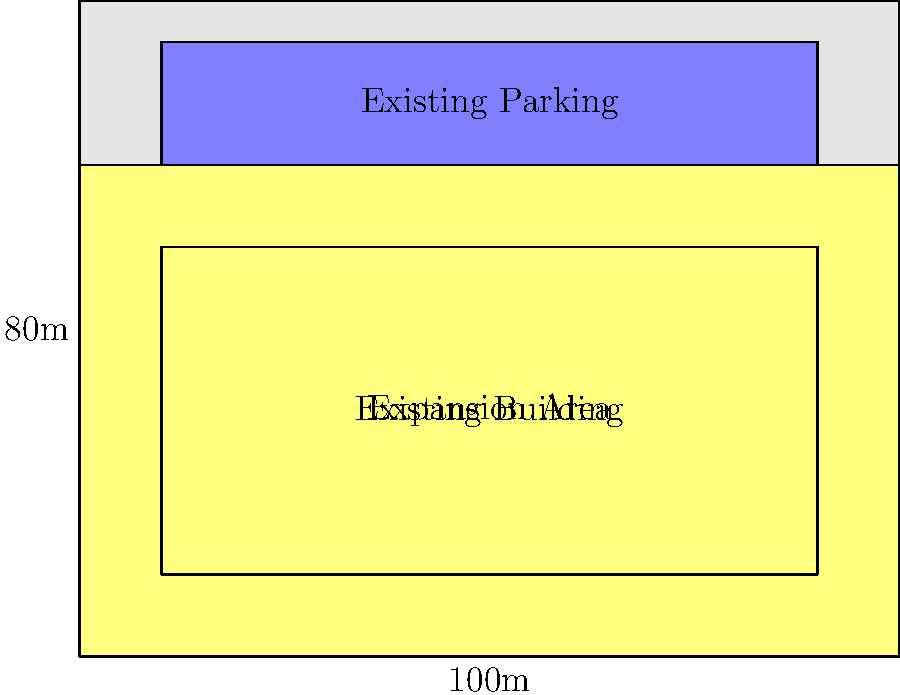As a family business owner looking to expand your operations, you've been presented with the following site plan for a parking lot expansion. Given that the expansion area is 100m wide and 60m deep, and assuming each parking space requires 5m x 2.5m, what is the maximum number of additional parking spaces that can be accommodated in the expansion area while maintaining a 6m wide two-way traffic lane through the center of the lot? To determine the maximum number of additional parking spaces, we'll follow these steps:

1. Calculate the total area of the expansion zone:
   Area = 100m × 60m = 6000 m²

2. Determine the space required for the central traffic lane:
   Lane area = 100m × 6m = 600 m²

3. Calculate the remaining area for parking spaces:
   Parking area = Total area - Lane area
   Parking area = 6000 m² - 600 m² = 5400 m²

4. Calculate the area required for each parking space:
   Space area = 5m × 2.5m = 12.5 m²

5. Determine the maximum number of parking spaces:
   Max spaces = Parking area ÷ Space area
   Max spaces = 5400 m² ÷ 12.5 m² = 432

6. Consider the layout:
   - The expansion area can accommodate two rows of parking on each side of the central lane.
   - Each row can fit 20 spaces (100m ÷ 5m = 20)
   - Total spaces in four rows: 4 × 20 = 80 spaces

7. Compare the calculated maximum with the layout-based number:
   The layout-based number (80) is less than the calculated maximum (432), so we use the layout-based number.

Therefore, the maximum number of additional parking spaces that can be accommodated while maintaining the required traffic lane is 80.
Answer: 80 parking spaces 